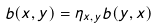<formula> <loc_0><loc_0><loc_500><loc_500>b ( x , y ) = \eta _ { x , y } b ( y , x )</formula> 